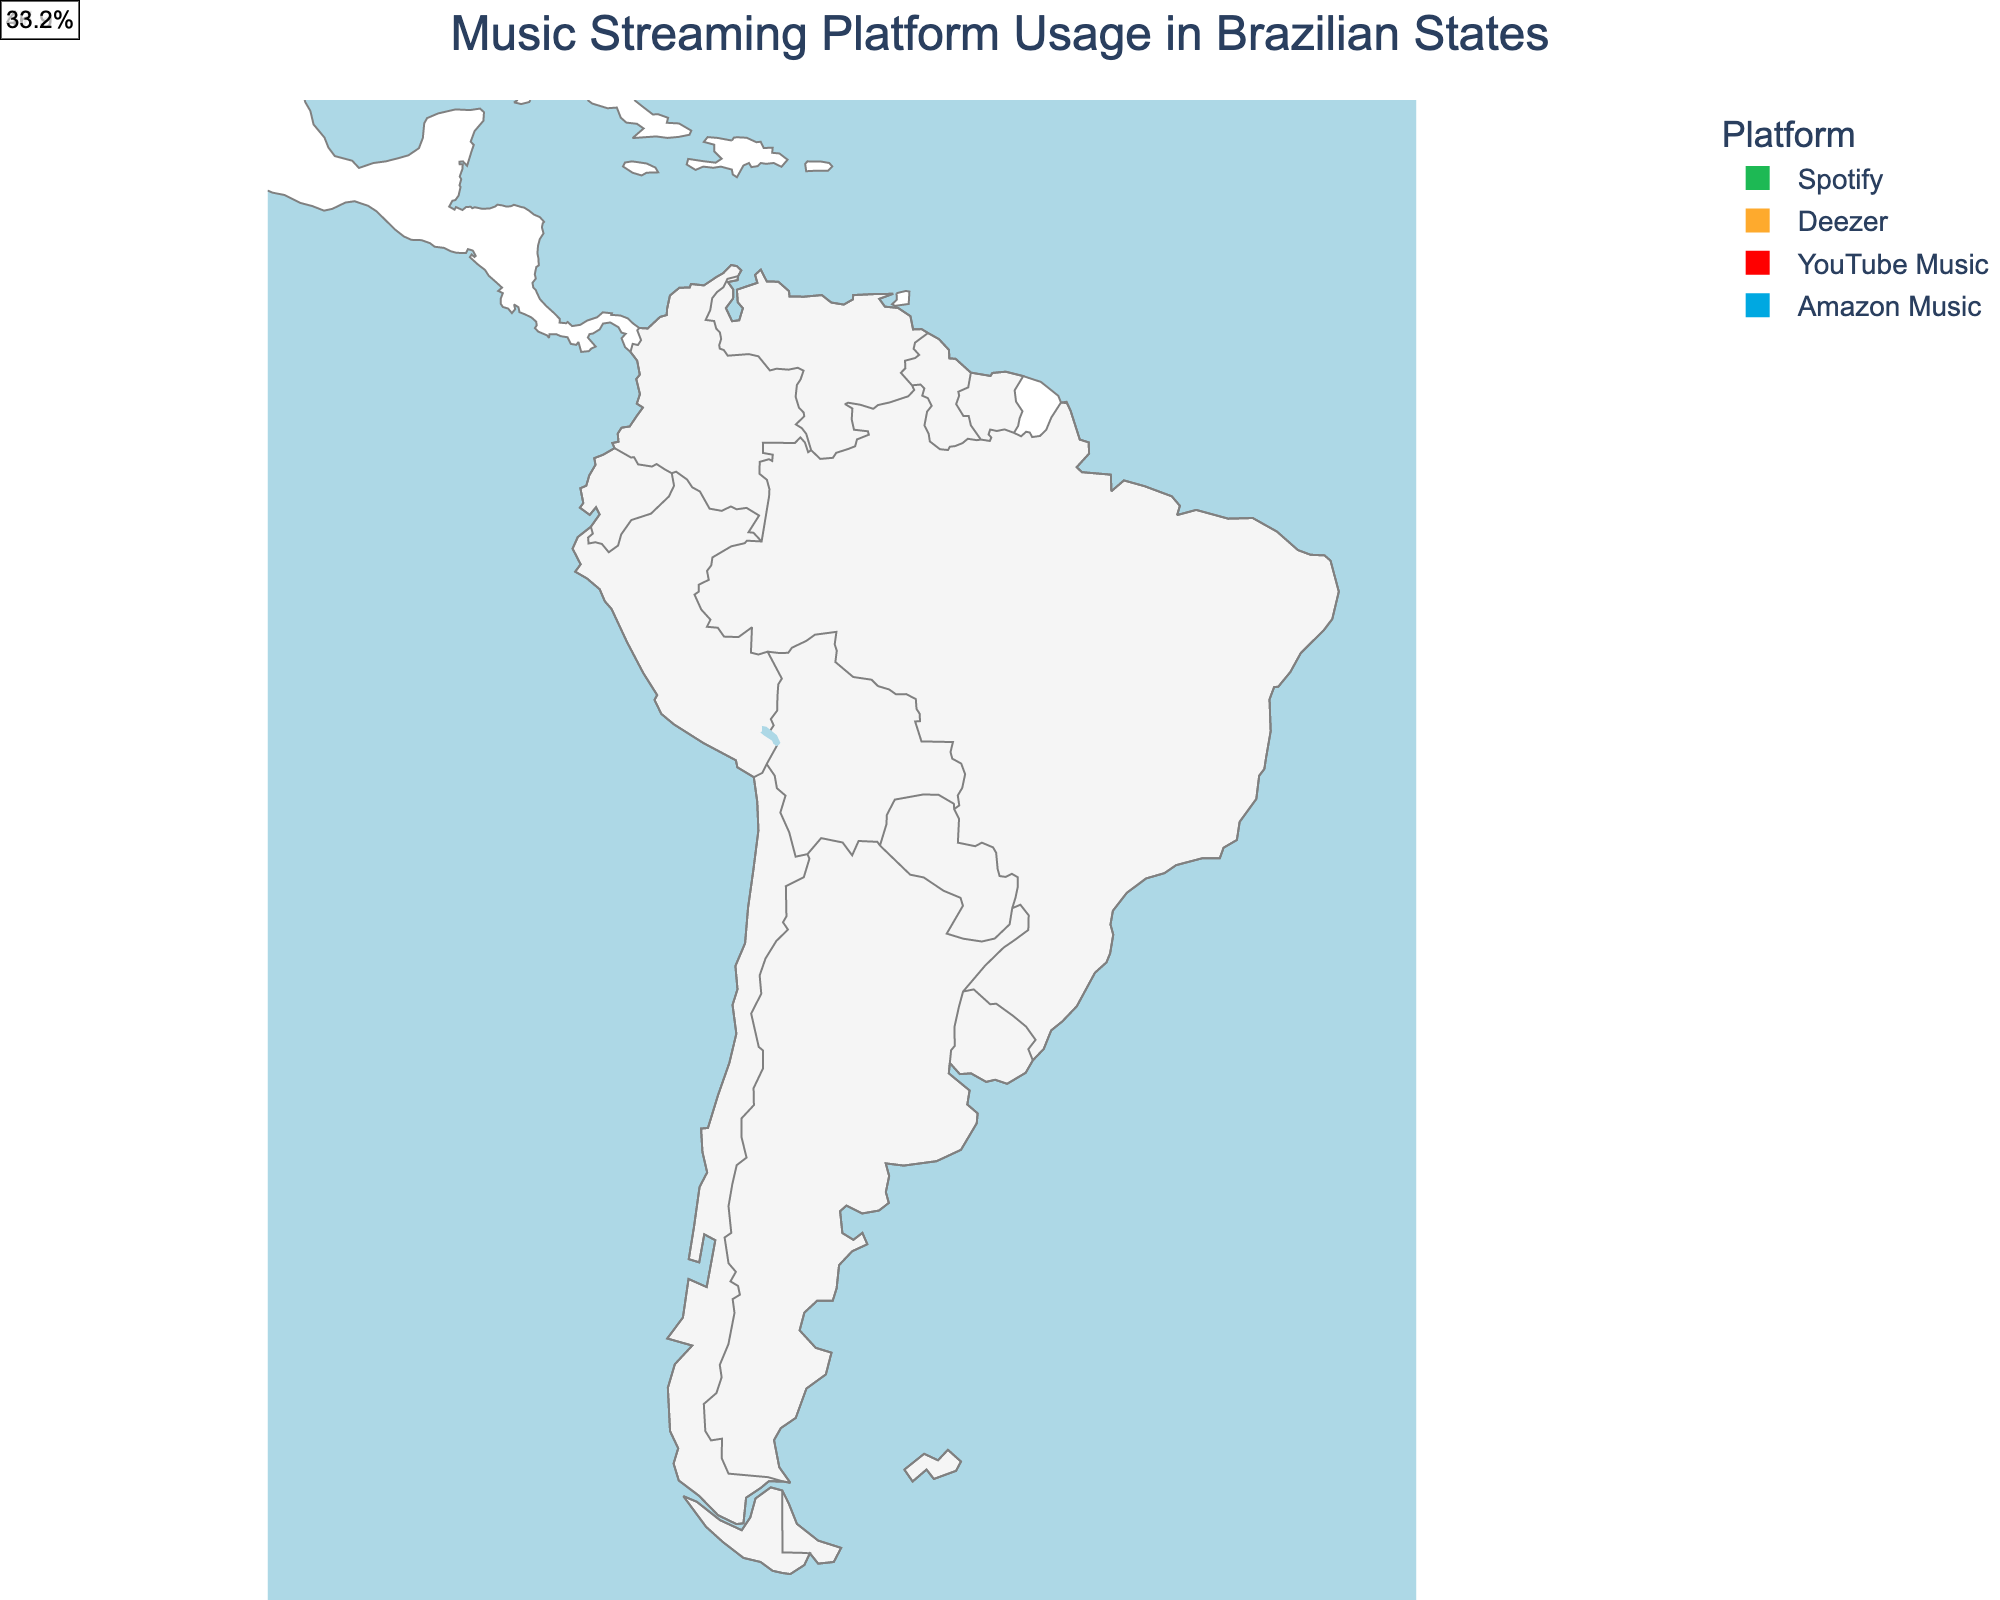What is the title of the figure? The title is typically displayed at the top of the plot which gives an overall context to what the figure represents. In this case, it should describe the main focus of the plot, which is related to music streaming usage in Brazilian states.
Answer: Music Streaming Platform Usage in Brazilian States Which state has the highest usage percentage for Spotify? To answer this, look at the data points marked for Spotify and identify the one with the highest usage percentage.
Answer: São Paulo How many states mainly use Deezer? Count the number of unique states where Deezer is the dominant platform based on the color coding.
Answer: 3 What is the average usage percentage of YouTube Music across the states it dominates? Add up the usage percentages for all states where YouTube Music is the dominant platform and divide by the number of these states. The states are Bahia (55.7), Pernambuco (51.2), Goiás (48.7), and Paraíba (46.9). 
Explanation: (55.7 + 51.2 + 48.7 + 46.9) / 4 = 202.5 / 4 = 50.625
Answer: 50.625 Which state has the lowest usage percentage overall, and which platform is dominant there? Look at all the provided usage percentages across states to find the minimum value and identify its corresponding platform and state.
Answer: Amazonas, Amazon Music How many states have a dominant usage percentage higher than 50%? Count the number of states where the usage percentages are greater than 50%.
Answer: 8 What is the dominant music streaming platform for the state of Rio Grande do Sul? Check the figure for the platform indicated for Rio Grande do Sul based on its color coding and labels.
Answer: Amazon Music Which platform dominates in Santa Catarina, and what is its usage percentage? Identify Santa Catarina on the plot and check the associated color or label for the platform and its usage percentage.
Answer: Spotify, 62.4 